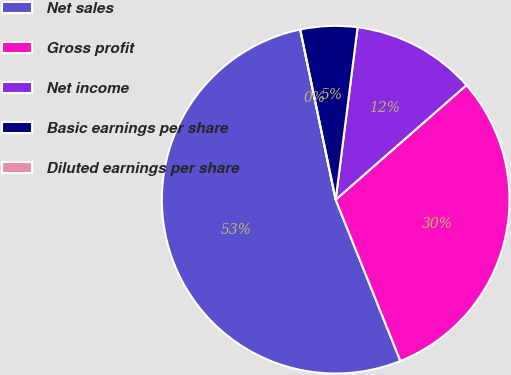Convert chart. <chart><loc_0><loc_0><loc_500><loc_500><pie_chart><fcel>Net sales<fcel>Gross profit<fcel>Net income<fcel>Basic earnings per share<fcel>Diluted earnings per share<nl><fcel>52.81%<fcel>30.38%<fcel>11.54%<fcel>5.28%<fcel>0.0%<nl></chart> 